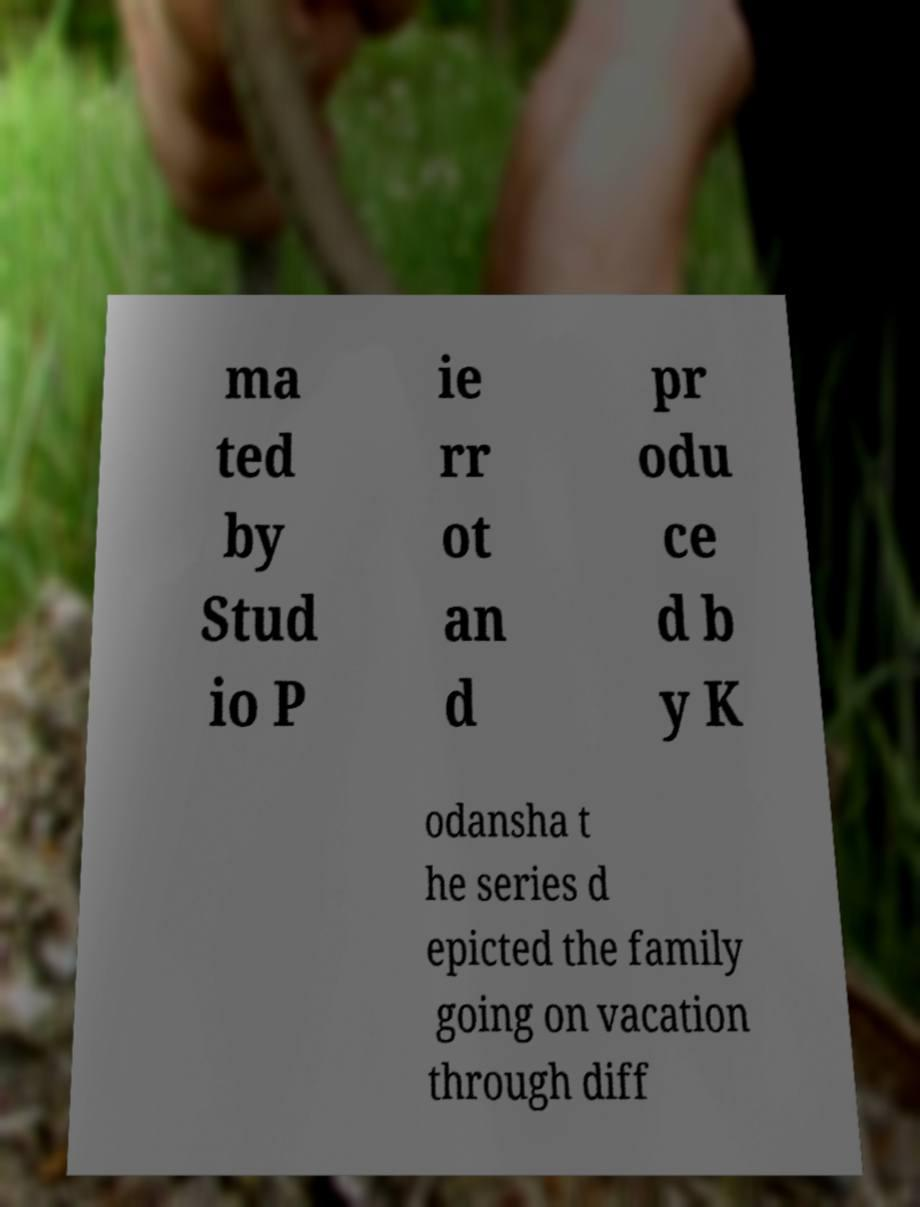For documentation purposes, I need the text within this image transcribed. Could you provide that? ma ted by Stud io P ie rr ot an d pr odu ce d b y K odansha t he series d epicted the family going on vacation through diff 